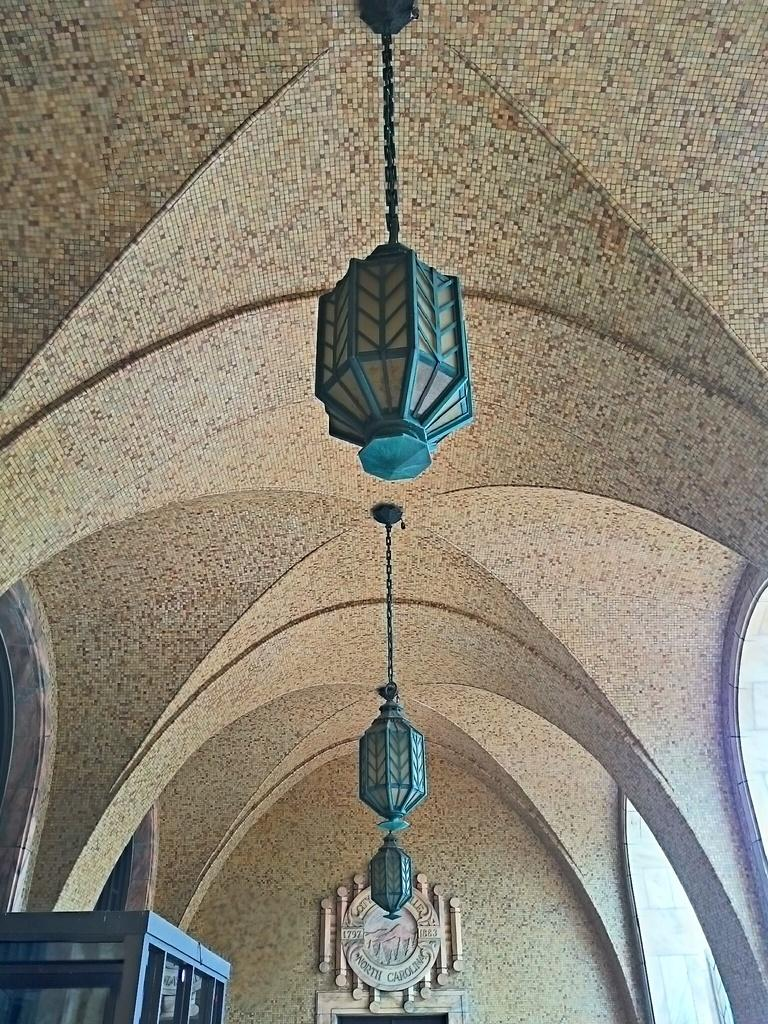What type of location is depicted in the image? The image shows an inside view of a building. What architectural feature is present in the image? There are windows in the image. What object can be seen in the image? There is a box in the image. What is the purpose of the frame in the image? There is a frame in the image, which might be used for displaying artwork or photographs. What is the source of light in the image? There is a light attached to the ceiling in the image. What type of fruit is displayed on the bookshelf in the image? There is no fruit or bookshelf present in the image. What book is being read by the person in the image? There is no person or book visible in the image. 